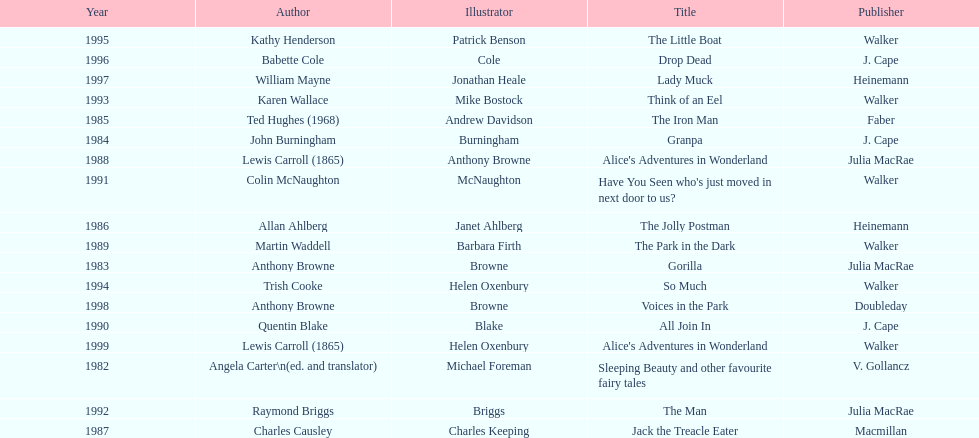How many titles did walker publish? 6. 